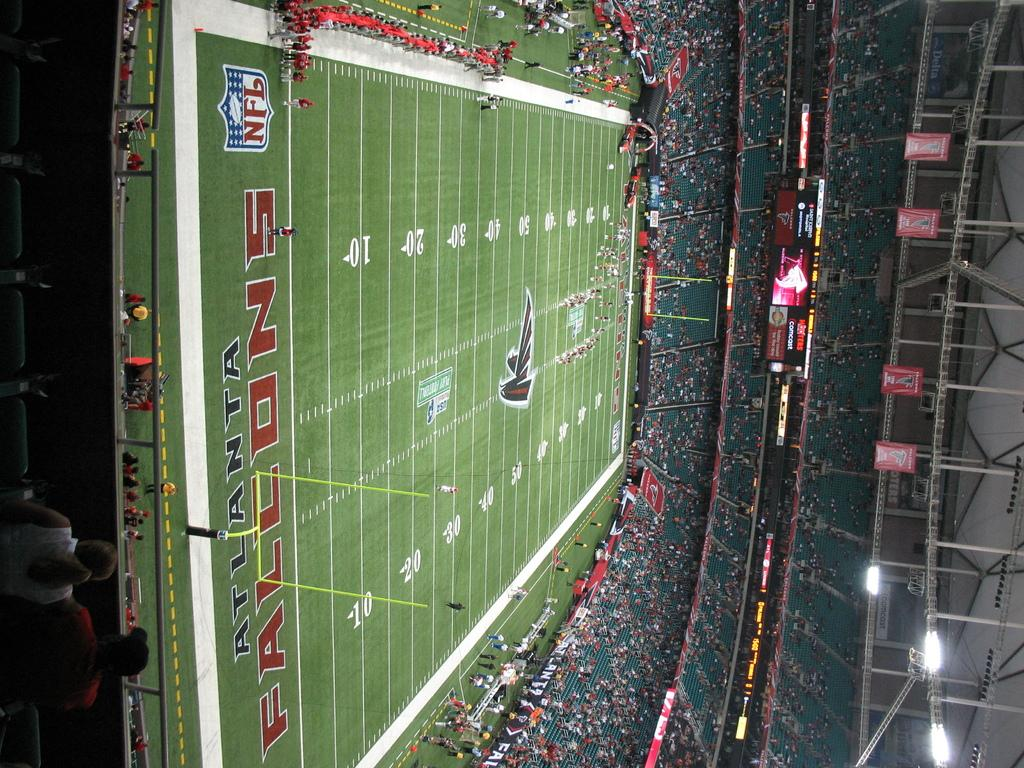What are the people in the image doing? There are people on the ground and sitting on chairs in the image. What objects can be seen in the image? There are objects visible in the image, but their specific nature is not mentioned in the facts. What can be seen in the background of the image? In the background of the image, there are banners, screens, rods, and lights. What type of print can be seen on the tail of the animal in the image? There is no animal or print present in the image. 